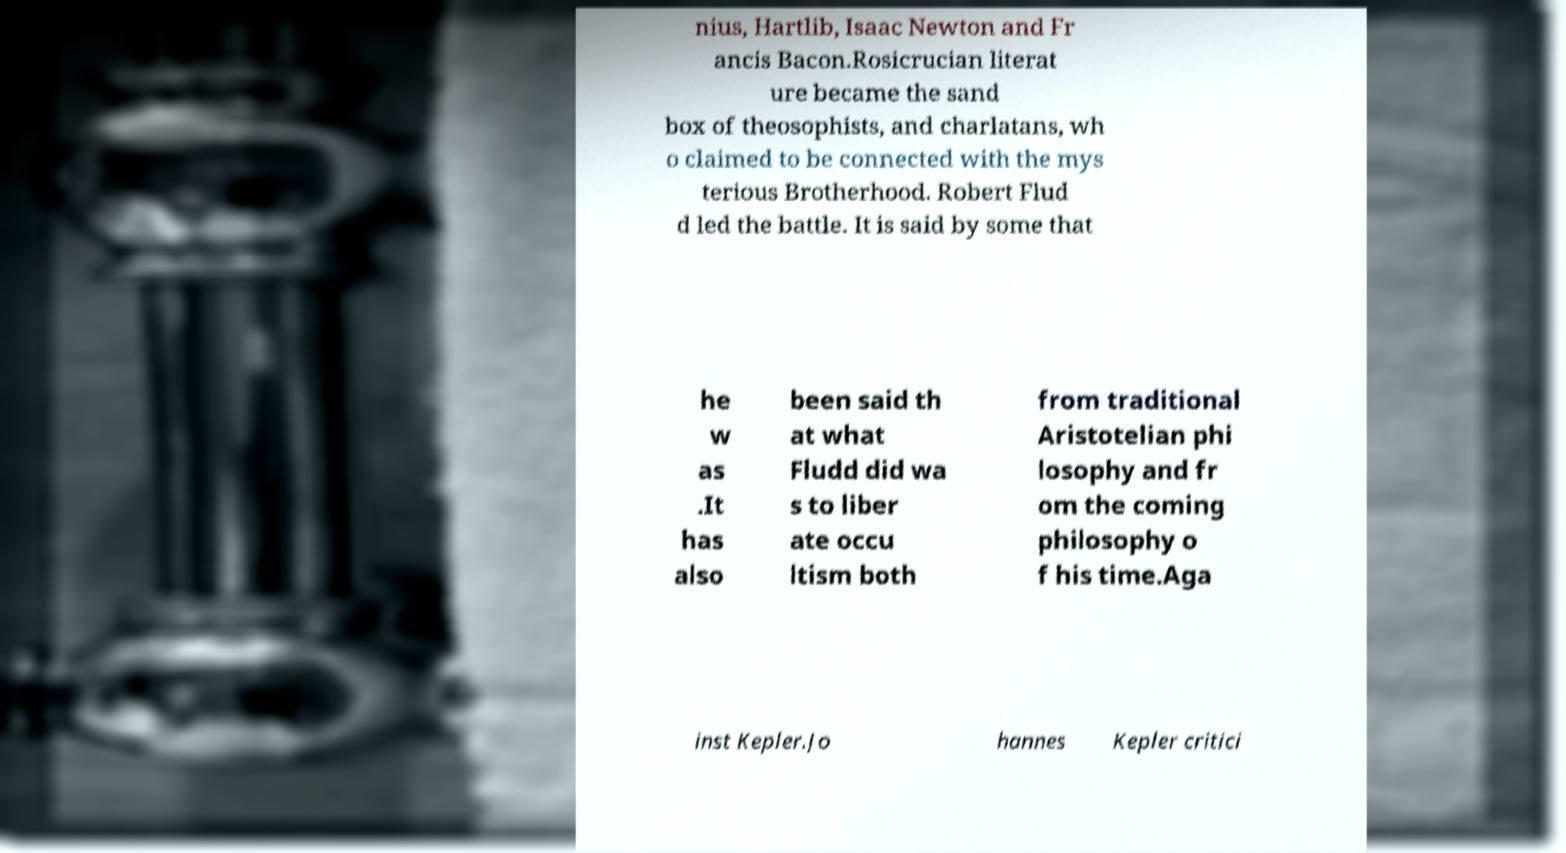For documentation purposes, I need the text within this image transcribed. Could you provide that? nius, Hartlib, Isaac Newton and Fr ancis Bacon.Rosicrucian literat ure became the sand box of theosophists, and charlatans, wh o claimed to be connected with the mys terious Brotherhood. Robert Flud d led the battle. It is said by some that he w as .It has also been said th at what Fludd did wa s to liber ate occu ltism both from traditional Aristotelian phi losophy and fr om the coming philosophy o f his time.Aga inst Kepler.Jo hannes Kepler critici 